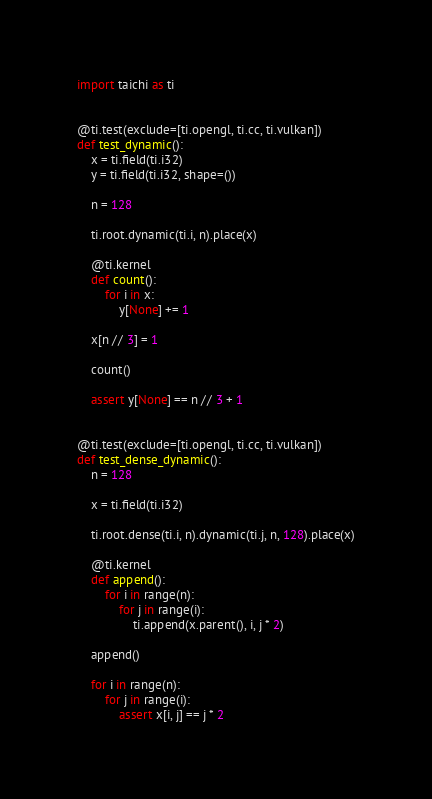<code> <loc_0><loc_0><loc_500><loc_500><_Python_>import taichi as ti


@ti.test(exclude=[ti.opengl, ti.cc, ti.vulkan])
def test_dynamic():
    x = ti.field(ti.i32)
    y = ti.field(ti.i32, shape=())

    n = 128

    ti.root.dynamic(ti.i, n).place(x)

    @ti.kernel
    def count():
        for i in x:
            y[None] += 1

    x[n // 3] = 1

    count()

    assert y[None] == n // 3 + 1


@ti.test(exclude=[ti.opengl, ti.cc, ti.vulkan])
def test_dense_dynamic():
    n = 128

    x = ti.field(ti.i32)

    ti.root.dense(ti.i, n).dynamic(ti.j, n, 128).place(x)

    @ti.kernel
    def append():
        for i in range(n):
            for j in range(i):
                ti.append(x.parent(), i, j * 2)

    append()

    for i in range(n):
        for j in range(i):
            assert x[i, j] == j * 2
</code> 